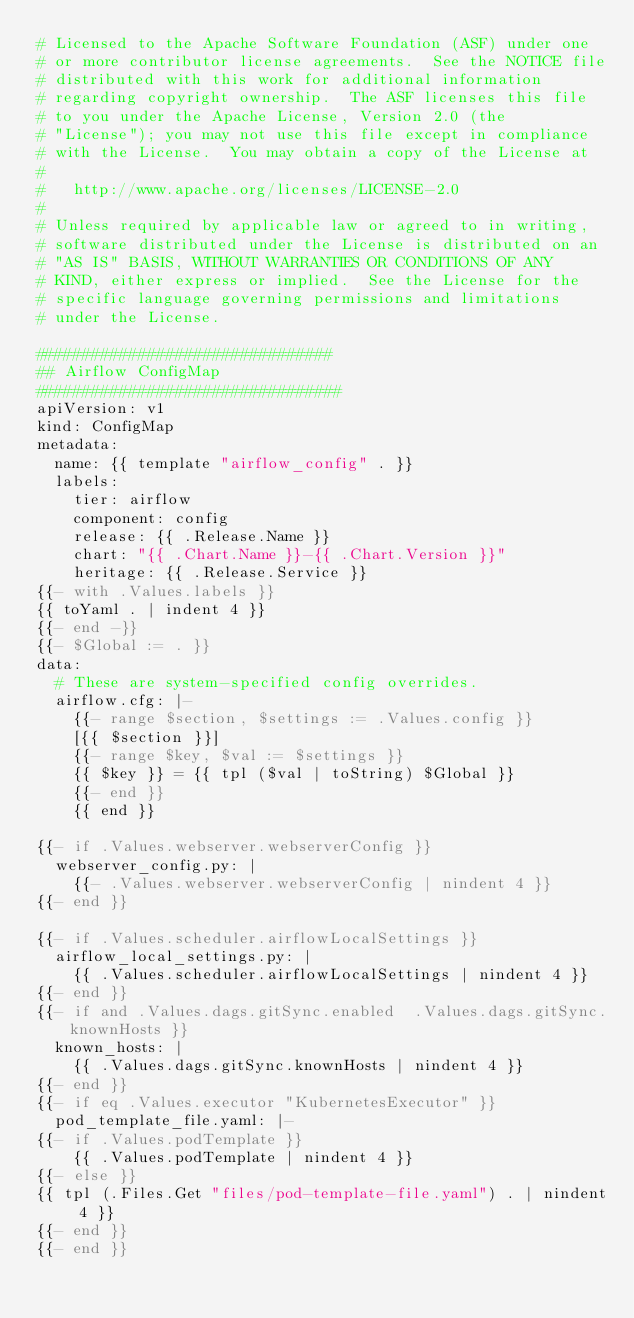Convert code to text. <code><loc_0><loc_0><loc_500><loc_500><_YAML_># Licensed to the Apache Software Foundation (ASF) under one
# or more contributor license agreements.  See the NOTICE file
# distributed with this work for additional information
# regarding copyright ownership.  The ASF licenses this file
# to you under the Apache License, Version 2.0 (the
# "License"); you may not use this file except in compliance
# with the License.  You may obtain a copy of the License at
#
#   http://www.apache.org/licenses/LICENSE-2.0
#
# Unless required by applicable law or agreed to in writing,
# software distributed under the License is distributed on an
# "AS IS" BASIS, WITHOUT WARRANTIES OR CONDITIONS OF ANY
# KIND, either express or implied.  See the License for the
# specific language governing permissions and limitations
# under the License.

################################
## Airflow ConfigMap
#################################
apiVersion: v1
kind: ConfigMap
metadata:
  name: {{ template "airflow_config" . }}
  labels:
    tier: airflow
    component: config
    release: {{ .Release.Name }}
    chart: "{{ .Chart.Name }}-{{ .Chart.Version }}"
    heritage: {{ .Release.Service }}
{{- with .Values.labels }}
{{ toYaml . | indent 4 }}
{{- end -}}
{{- $Global := . }}
data:
  # These are system-specified config overrides.
  airflow.cfg: |-
    {{- range $section, $settings := .Values.config }}
    [{{ $section }}]
    {{- range $key, $val := $settings }}
    {{ $key }} = {{ tpl ($val | toString) $Global }}
    {{- end }}
    {{ end }}

{{- if .Values.webserver.webserverConfig }}
  webserver_config.py: |
    {{- .Values.webserver.webserverConfig | nindent 4 }}
{{- end }}

{{- if .Values.scheduler.airflowLocalSettings }}
  airflow_local_settings.py: |
    {{ .Values.scheduler.airflowLocalSettings | nindent 4 }}
{{- end }}
{{- if and .Values.dags.gitSync.enabled  .Values.dags.gitSync.knownHosts }}
  known_hosts: |
    {{ .Values.dags.gitSync.knownHosts | nindent 4 }}
{{- end }}
{{- if eq .Values.executor "KubernetesExecutor" }}
  pod_template_file.yaml: |-
{{- if .Values.podTemplate }}
    {{ .Values.podTemplate | nindent 4 }}
{{- else }}
{{ tpl (.Files.Get "files/pod-template-file.yaml") . | nindent 4 }}
{{- end }}
{{- end }}
</code> 